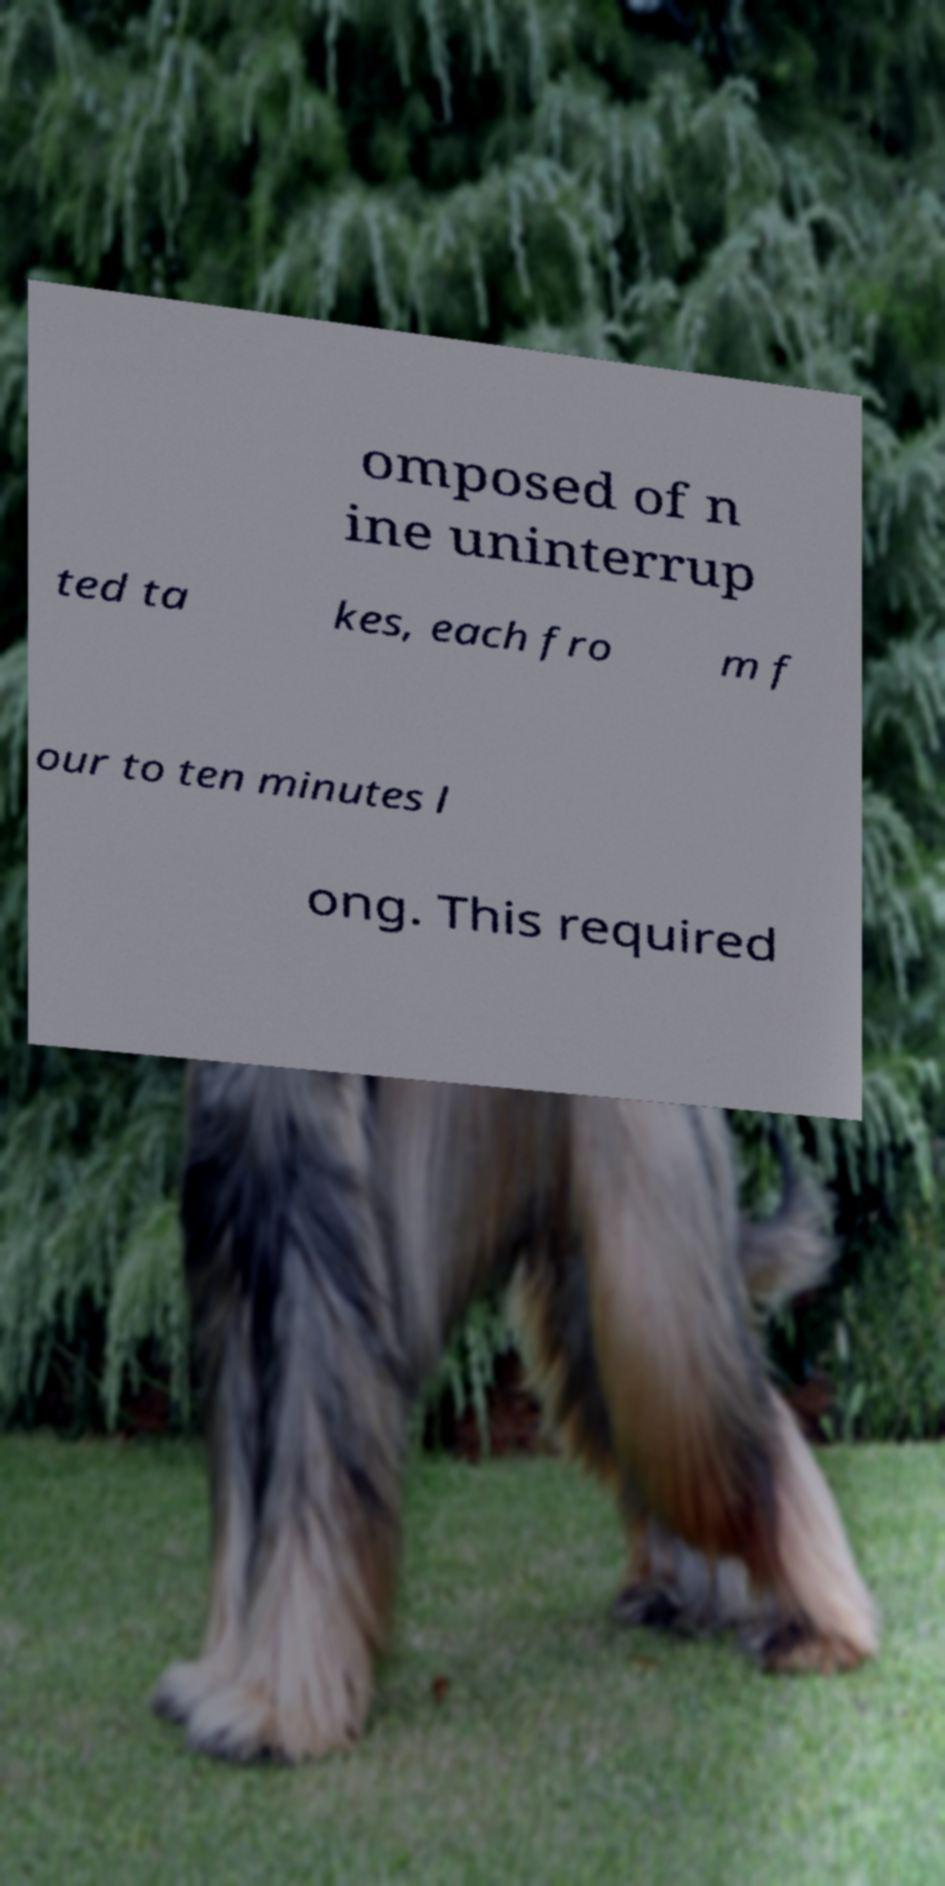Can you read and provide the text displayed in the image?This photo seems to have some interesting text. Can you extract and type it out for me? omposed of n ine uninterrup ted ta kes, each fro m f our to ten minutes l ong. This required 